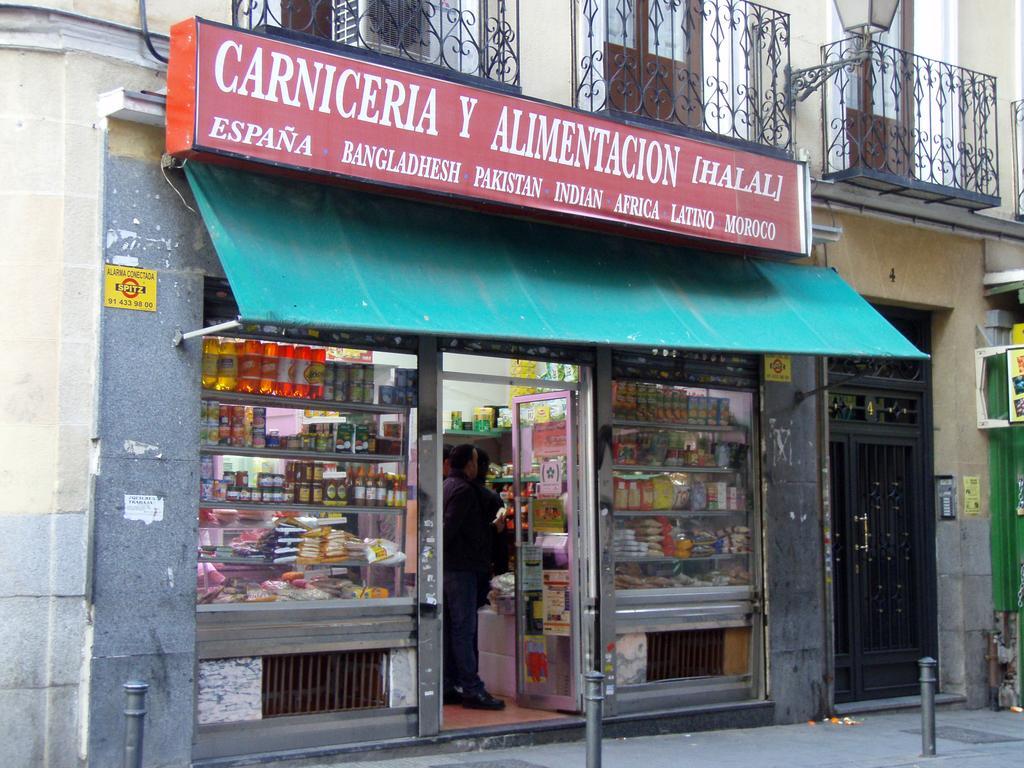Please provide a concise description of this image. In this image we can see there is a store in the middle. Above the store there is a building. In the store we can see that there are so many things kept in the racks like bottles,packets. There are few persons in the store. At the bottom there is a footpath on which there are poles. On the right side there is a gate. At the top of the store there is a hoarding. 